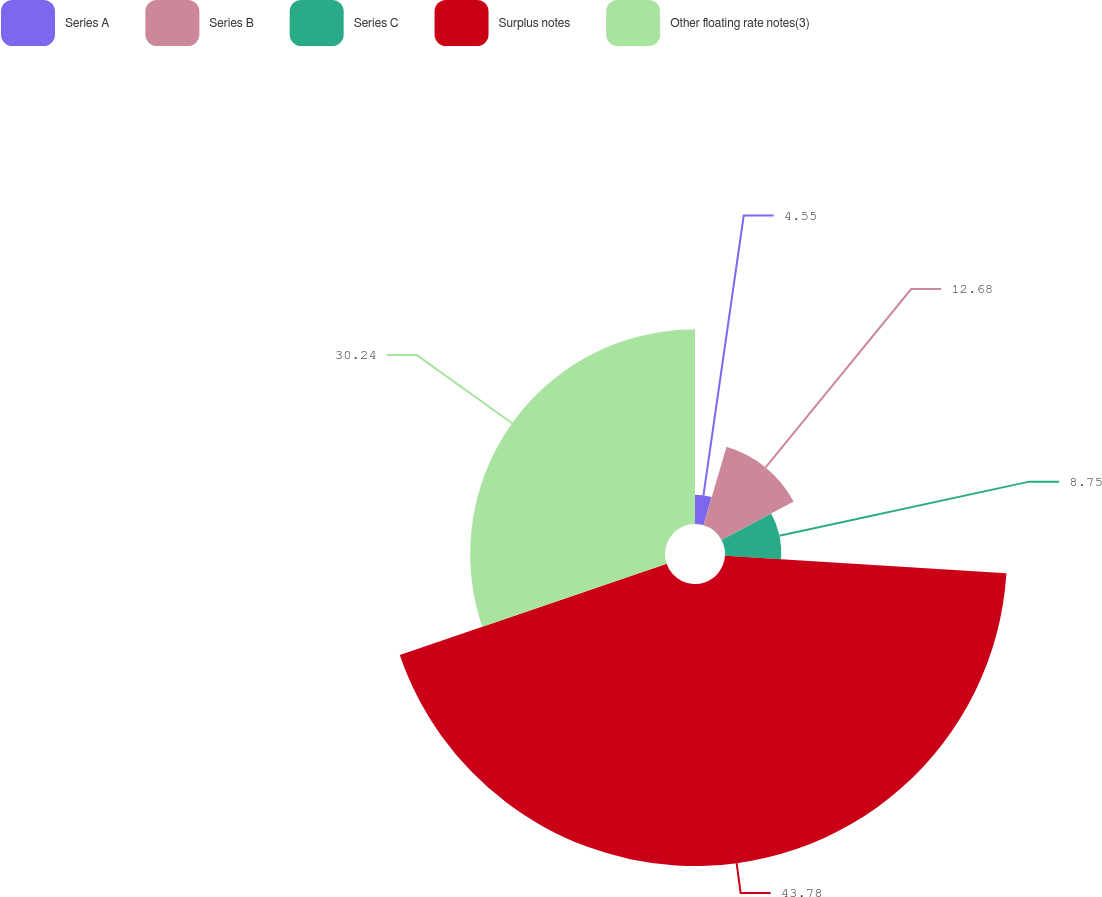Convert chart. <chart><loc_0><loc_0><loc_500><loc_500><pie_chart><fcel>Series A<fcel>Series B<fcel>Series C<fcel>Surplus notes<fcel>Other floating rate notes(3)<nl><fcel>4.55%<fcel>12.68%<fcel>8.75%<fcel>43.77%<fcel>30.24%<nl></chart> 